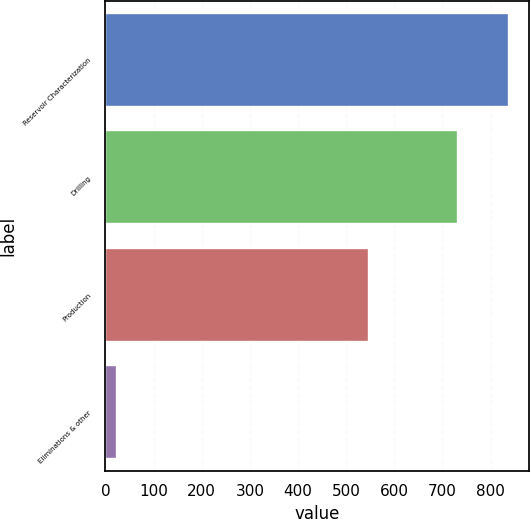Convert chart. <chart><loc_0><loc_0><loc_500><loc_500><bar_chart><fcel>Reservoir Characterization<fcel>Drilling<fcel>Production<fcel>Eliminations & other<nl><fcel>838<fcel>733<fcel>548<fcel>23<nl></chart> 